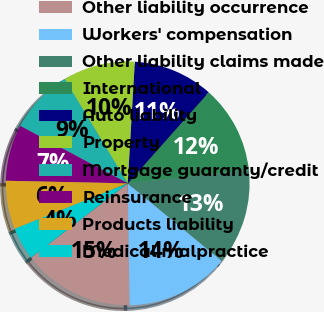Convert chart. <chart><loc_0><loc_0><loc_500><loc_500><pie_chart><fcel>Other liability occurrence<fcel>Workers' compensation<fcel>Other liability claims made<fcel>International<fcel>Auto liability<fcel>Property<fcel>Mortgage guaranty/credit<fcel>Reinsurance<fcel>Products liability<fcel>Medical malpractice<nl><fcel>14.83%<fcel>13.78%<fcel>12.73%<fcel>11.68%<fcel>10.63%<fcel>9.58%<fcel>8.53%<fcel>7.48%<fcel>6.43%<fcel>4.33%<nl></chart> 